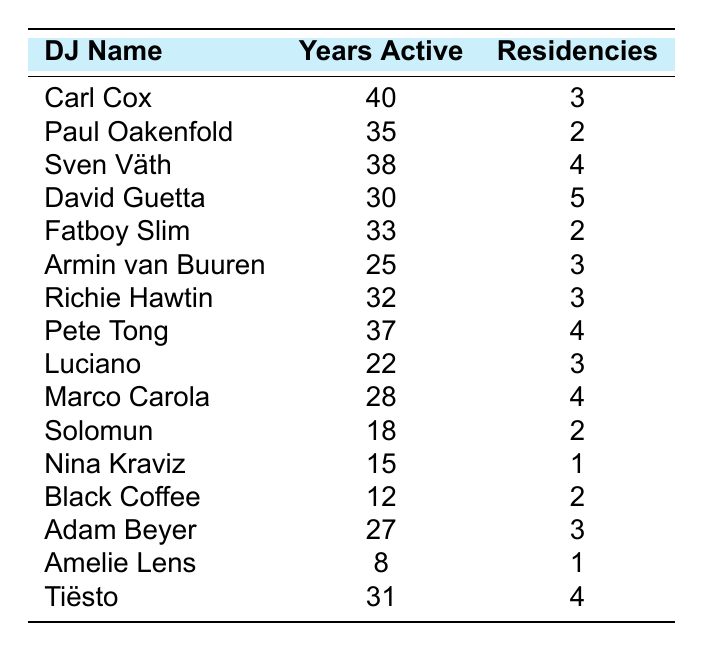What DJ has the longest career? Carl Cox has the longest career with 40 years active as a DJ.
Answer: Carl Cox Which DJ has the most residencies? David Guetta has the most residencies with 5 in total.
Answer: David Guetta What is the average number of residencies among the listed DJs? To find the average, sum the number of residencies (3 + 2 + 4 + 5 + 2 + 3 + 3 + 4 + 3 + 4 + 2 + 1 + 2 + 3 + 1 + 4) = 49, then divide by the number of DJs (16). The average is 49/16 = 3.06, which rounds to approximately 3.1.
Answer: 3.1 True or False: Amelie Lens has more than 10 years of active DJ experience. Amelie Lens has 8 years of active DJ experience, which is not more than 10.
Answer: False Which DJ has the fewest years active? Amelie Lens has the fewest years active, with only 8 years in the industry.
Answer: Amelie Lens If you consider the top three DJs by years active, how many total years have they been active? The top three DJs by years active are Carl Cox (40), Sven Väth (38), and Paul Oakenfold (35). Adding these gives 40 + 38 + 35 = 113 total years active.
Answer: 113 Which DJ has 4 residencies and 28 years active? Marco Carola has 4 residencies and 28 years active.
Answer: Marco Carola How many DJs have 2 residencies? There are three DJs with 2 residencies: Paul Oakenfold, Fatboy Slim, and Black Coffee.
Answer: 3 True or False: All DJs who have been active for over 30 years have at least 3 residencies. David Guetta, who has been active for 30 years, has 5 residencies. However, Carl Cox (40 years) and Sven Väth (38 years) also meet this criterion with their respective residencies (3 and 4). All others over that time also have at least 3 residencies.
Answer: True What is the difference in years active between the most active DJ and the least active DJ? The most active DJ is Carl Cox with 40 years, and the least active is Amelie Lens with 8 years. The difference is 40 - 8 = 32 years.
Answer: 32 